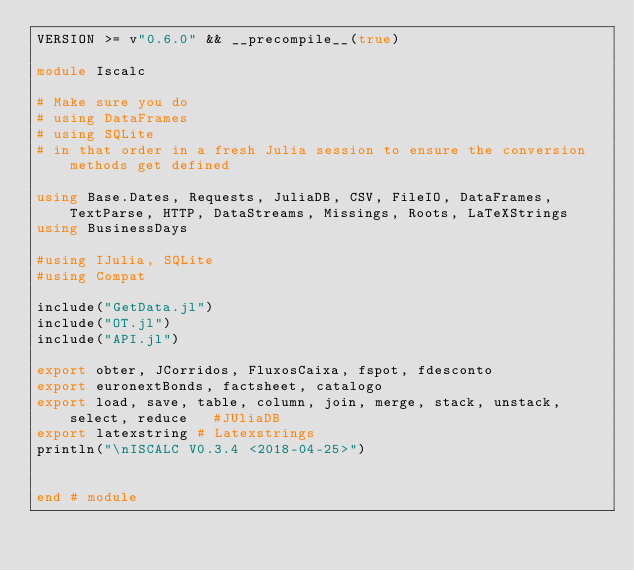Convert code to text. <code><loc_0><loc_0><loc_500><loc_500><_Julia_>VERSION >= v"0.6.0" && __precompile__(true)

module Iscalc

# Make sure you do
# using DataFrames
# using SQLite
# in that order in a fresh Julia session to ensure the conversion methods get defined

using Base.Dates, Requests, JuliaDB, CSV, FileIO, DataFrames, TextParse, HTTP, DataStreams, Missings, Roots, LaTeXStrings
using BusinessDays

#using IJulia, SQLite
#using Compat

include("GetData.jl")   
include("OT.jl")      
include("API.jl")

export obter, JCorridos, FluxosCaixa, fspot, fdesconto
export euronextBonds, factsheet, catalogo
export load, save, table, column, join, merge, stack, unstack, select, reduce   #JUliaDB
export latexstring # Latexstrings
println("\nISCALC V0.3.4 <2018-04-25>")


end # module
</code> 